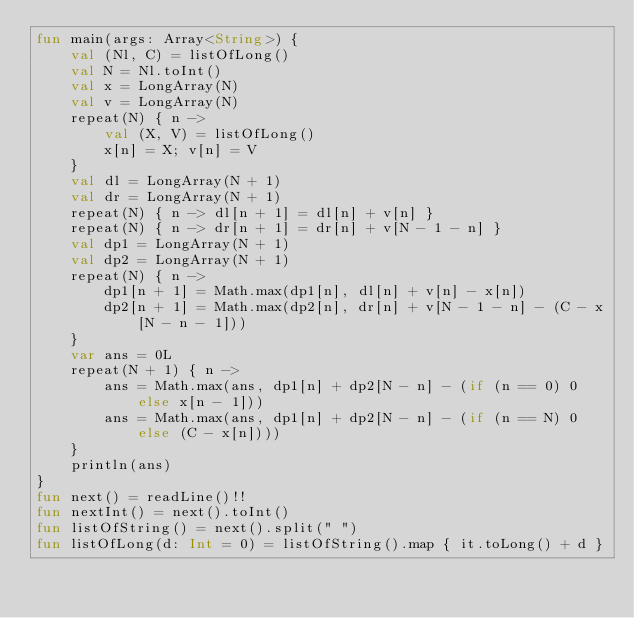<code> <loc_0><loc_0><loc_500><loc_500><_Kotlin_>fun main(args: Array<String>) {
    val (Nl, C) = listOfLong()
    val N = Nl.toInt()
    val x = LongArray(N)
    val v = LongArray(N)
    repeat(N) { n ->
        val (X, V) = listOfLong()
        x[n] = X; v[n] = V
    }
    val dl = LongArray(N + 1)
    val dr = LongArray(N + 1)
    repeat(N) { n -> dl[n + 1] = dl[n] + v[n] }
    repeat(N) { n -> dr[n + 1] = dr[n] + v[N - 1 - n] }
    val dp1 = LongArray(N + 1)
    val dp2 = LongArray(N + 1)
    repeat(N) { n ->
        dp1[n + 1] = Math.max(dp1[n], dl[n] + v[n] - x[n])
        dp2[n + 1] = Math.max(dp2[n], dr[n] + v[N - 1 - n] - (C - x[N - n - 1]))
    }
    var ans = 0L
    repeat(N + 1) { n ->
        ans = Math.max(ans, dp1[n] + dp2[N - n] - (if (n == 0) 0 else x[n - 1]))
        ans = Math.max(ans, dp1[n] + dp2[N - n] - (if (n == N) 0 else (C - x[n])))
    }
    println(ans)
}
fun next() = readLine()!!
fun nextInt() = next().toInt()
fun listOfString() = next().split(" ")
fun listOfLong(d: Int = 0) = listOfString().map { it.toLong() + d }
</code> 